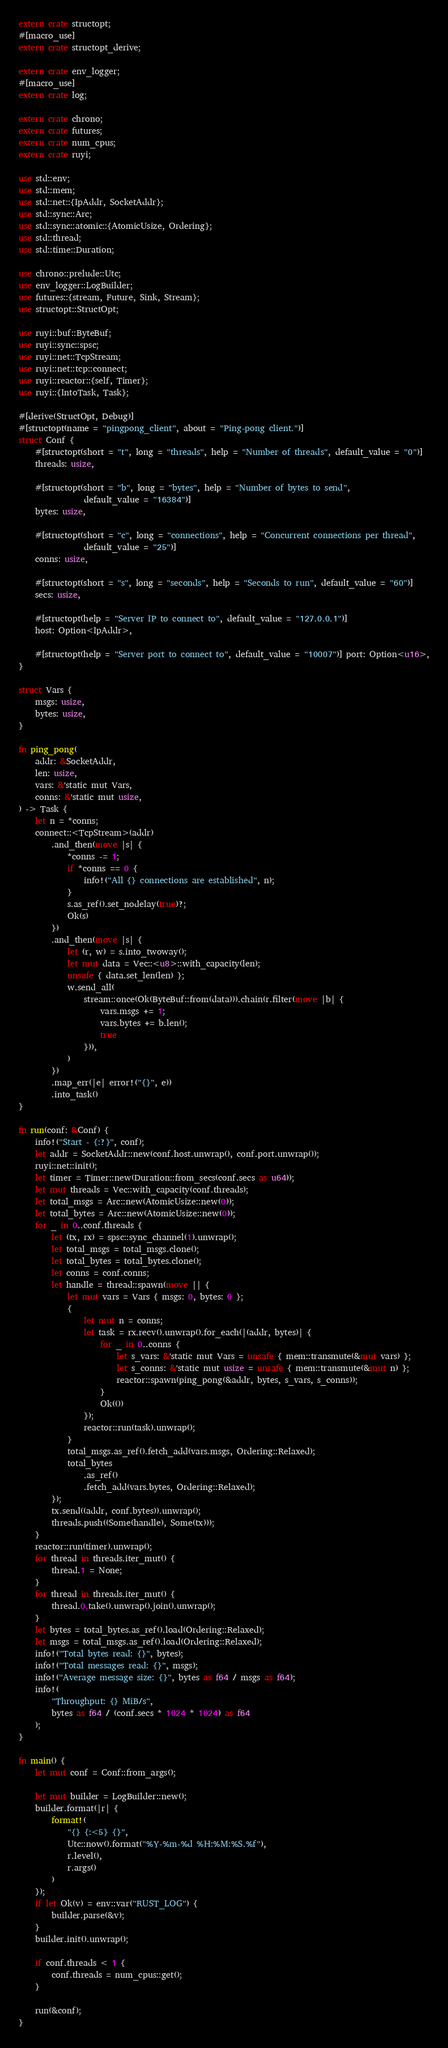<code> <loc_0><loc_0><loc_500><loc_500><_Rust_>extern crate structopt;
#[macro_use]
extern crate structopt_derive;

extern crate env_logger;
#[macro_use]
extern crate log;

extern crate chrono;
extern crate futures;
extern crate num_cpus;
extern crate ruyi;

use std::env;
use std::mem;
use std::net::{IpAddr, SocketAddr};
use std::sync::Arc;
use std::sync::atomic::{AtomicUsize, Ordering};
use std::thread;
use std::time::Duration;

use chrono::prelude::Utc;
use env_logger::LogBuilder;
use futures::{stream, Future, Sink, Stream};
use structopt::StructOpt;

use ruyi::buf::ByteBuf;
use ruyi::sync::spsc;
use ruyi::net::TcpStream;
use ruyi::net::tcp::connect;
use ruyi::reactor::{self, Timer};
use ruyi::{IntoTask, Task};

#[derive(StructOpt, Debug)]
#[structopt(name = "pingpong_client", about = "Ping-pong client.")]
struct Conf {
    #[structopt(short = "t", long = "threads", help = "Number of threads", default_value = "0")]
    threads: usize,

    #[structopt(short = "b", long = "bytes", help = "Number of bytes to send",
                default_value = "16384")]
    bytes: usize,

    #[structopt(short = "c", long = "connections", help = "Concurrent connections per thread",
                default_value = "25")]
    conns: usize,

    #[structopt(short = "s", long = "seconds", help = "Seconds to run", default_value = "60")]
    secs: usize,

    #[structopt(help = "Server IP to connect to", default_value = "127.0.0.1")]
    host: Option<IpAddr>,

    #[structopt(help = "Server port to connect to", default_value = "10007")] port: Option<u16>,
}

struct Vars {
    msgs: usize,
    bytes: usize,
}

fn ping_pong(
    addr: &SocketAddr,
    len: usize,
    vars: &'static mut Vars,
    conns: &'static mut usize,
) -> Task {
    let n = *conns;
    connect::<TcpStream>(addr)
        .and_then(move |s| {
            *conns -= 1;
            if *conns == 0 {
                info!("All {} connections are established", n);
            }
            s.as_ref().set_nodelay(true)?;
            Ok(s)
        })
        .and_then(move |s| {
            let (r, w) = s.into_twoway();
            let mut data = Vec::<u8>::with_capacity(len);
            unsafe { data.set_len(len) };
            w.send_all(
                stream::once(Ok(ByteBuf::from(data))).chain(r.filter(move |b| {
                    vars.msgs += 1;
                    vars.bytes += b.len();
                    true
                })),
            )
        })
        .map_err(|e| error!("{}", e))
        .into_task()
}

fn run(conf: &Conf) {
    info!("Start - {:?}", conf);
    let addr = SocketAddr::new(conf.host.unwrap(), conf.port.unwrap());
    ruyi::net::init();
    let timer = Timer::new(Duration::from_secs(conf.secs as u64));
    let mut threads = Vec::with_capacity(conf.threads);
    let total_msgs = Arc::new(AtomicUsize::new(0));
    let total_bytes = Arc::new(AtomicUsize::new(0));
    for _ in 0..conf.threads {
        let (tx, rx) = spsc::sync_channel(1).unwrap();
        let total_msgs = total_msgs.clone();
        let total_bytes = total_bytes.clone();
        let conns = conf.conns;
        let handle = thread::spawn(move || {
            let mut vars = Vars { msgs: 0, bytes: 0 };
            {
                let mut n = conns;
                let task = rx.recv().unwrap().for_each(|(addr, bytes)| {
                    for _ in 0..conns {
                        let s_vars: &'static mut Vars = unsafe { mem::transmute(&mut vars) };
                        let s_conns: &'static mut usize = unsafe { mem::transmute(&mut n) };
                        reactor::spawn(ping_pong(&addr, bytes, s_vars, s_conns));
                    }
                    Ok(())
                });
                reactor::run(task).unwrap();
            }
            total_msgs.as_ref().fetch_add(vars.msgs, Ordering::Relaxed);
            total_bytes
                .as_ref()
                .fetch_add(vars.bytes, Ordering::Relaxed);
        });
        tx.send((addr, conf.bytes)).unwrap();
        threads.push((Some(handle), Some(tx)));
    }
    reactor::run(timer).unwrap();
    for thread in threads.iter_mut() {
        thread.1 = None;
    }
    for thread in threads.iter_mut() {
        thread.0.take().unwrap().join().unwrap();
    }
    let bytes = total_bytes.as_ref().load(Ordering::Relaxed);
    let msgs = total_msgs.as_ref().load(Ordering::Relaxed);
    info!("Total bytes read: {}", bytes);
    info!("Total messages read: {}", msgs);
    info!("Average message size: {}", bytes as f64 / msgs as f64);
    info!(
        "Throughput: {} MiB/s",
        bytes as f64 / (conf.secs * 1024 * 1024) as f64
    );
}

fn main() {
    let mut conf = Conf::from_args();

    let mut builder = LogBuilder::new();
    builder.format(|r| {
        format!(
            "{} {:<5} {}",
            Utc::now().format("%Y-%m-%d %H:%M:%S.%f"),
            r.level(),
            r.args()
        )
    });
    if let Ok(v) = env::var("RUST_LOG") {
        builder.parse(&v);
    }
    builder.init().unwrap();

    if conf.threads < 1 {
        conf.threads = num_cpus::get();
    }

    run(&conf);
}
</code> 